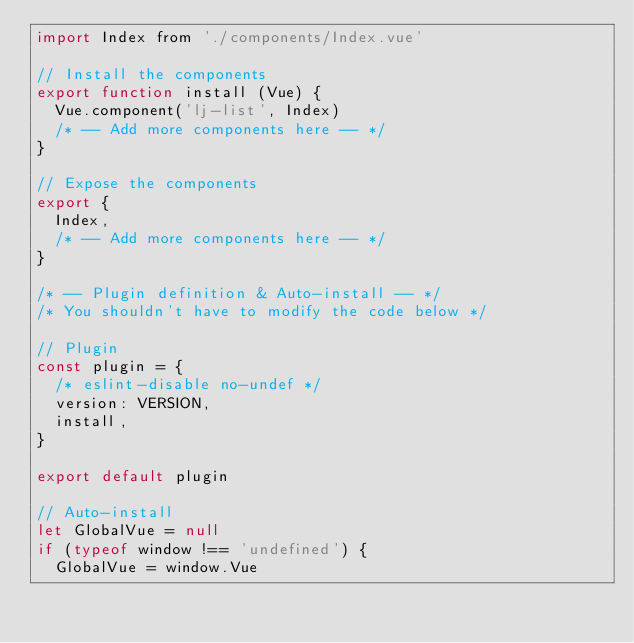Convert code to text. <code><loc_0><loc_0><loc_500><loc_500><_JavaScript_>import Index from './components/Index.vue'

// Install the components
export function install (Vue) {
  Vue.component('lj-list', Index)
  /* -- Add more components here -- */
}

// Expose the components
export {
  Index,
  /* -- Add more components here -- */
}

/* -- Plugin definition & Auto-install -- */
/* You shouldn't have to modify the code below */

// Plugin
const plugin = {
  /* eslint-disable no-undef */
  version: VERSION,
  install,
}

export default plugin

// Auto-install
let GlobalVue = null
if (typeof window !== 'undefined') {
  GlobalVue = window.Vue</code> 